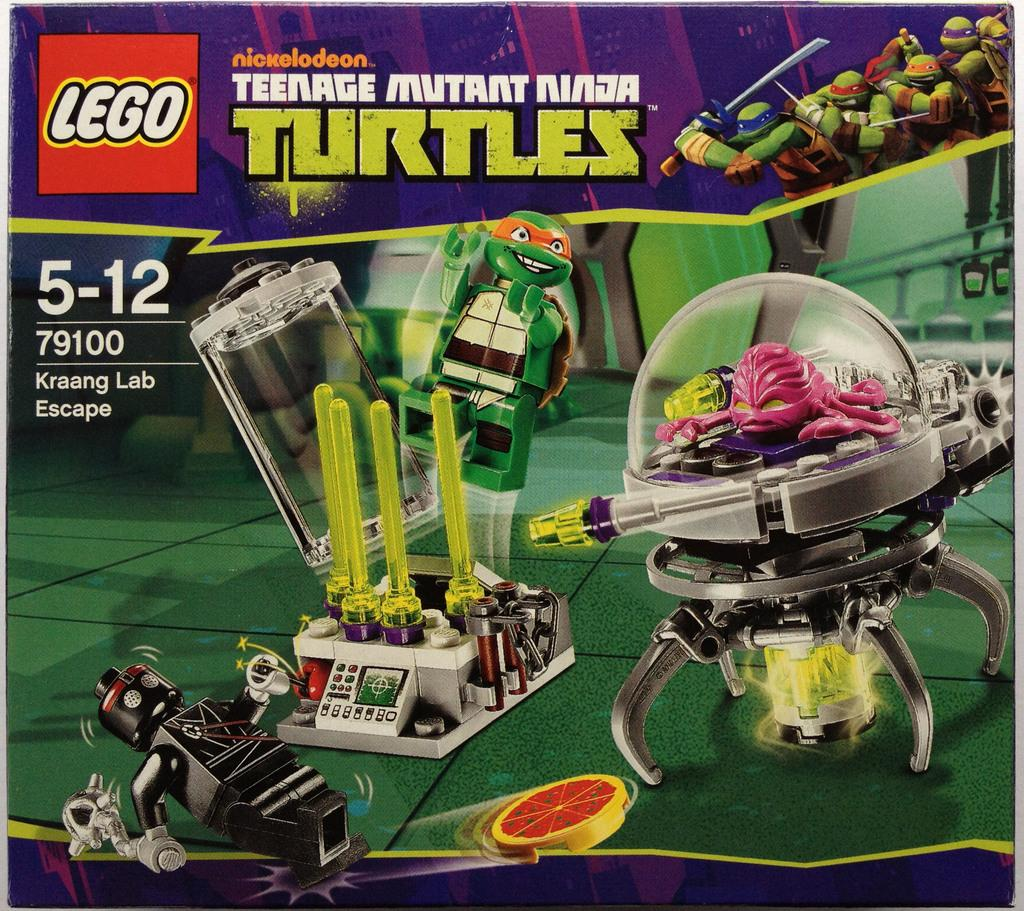Provide a one-sentence caption for the provided image. The Lego company has partnered with Nickelodeon to bring you a Teenage Mutant Ninja Turtles play set. 